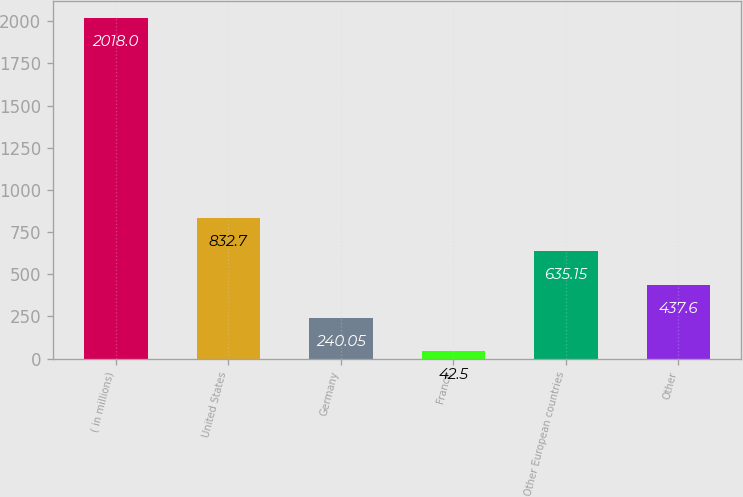Convert chart. <chart><loc_0><loc_0><loc_500><loc_500><bar_chart><fcel>( in millions)<fcel>United States<fcel>Germany<fcel>France<fcel>Other European countries<fcel>Other<nl><fcel>2018<fcel>832.7<fcel>240.05<fcel>42.5<fcel>635.15<fcel>437.6<nl></chart> 